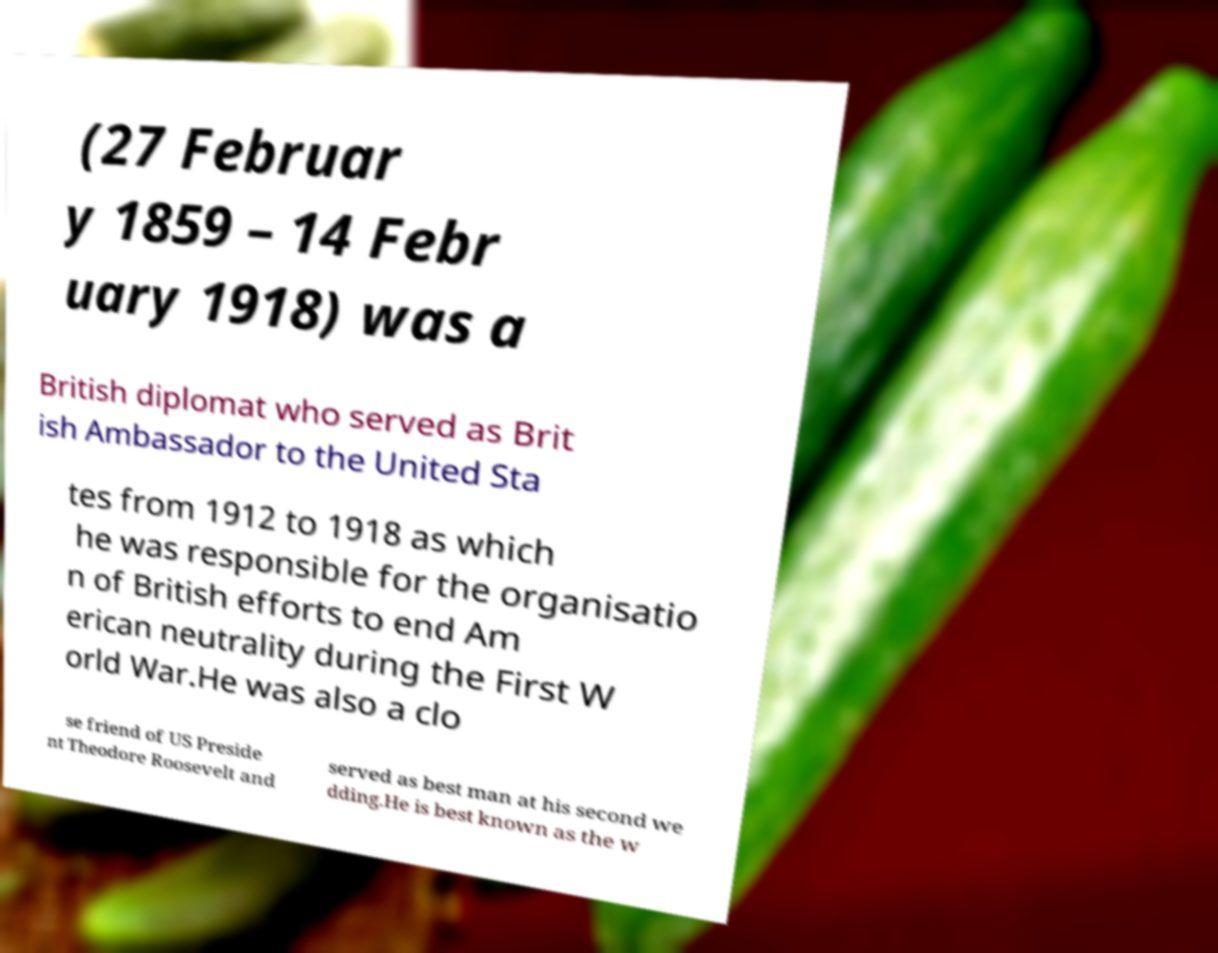Please read and relay the text visible in this image. What does it say? (27 Februar y 1859 – 14 Febr uary 1918) was a British diplomat who served as Brit ish Ambassador to the United Sta tes from 1912 to 1918 as which he was responsible for the organisatio n of British efforts to end Am erican neutrality during the First W orld War.He was also a clo se friend of US Preside nt Theodore Roosevelt and served as best man at his second we dding.He is best known as the w 